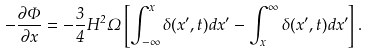Convert formula to latex. <formula><loc_0><loc_0><loc_500><loc_500>- \frac { \partial \Phi } { \partial x } = - \frac { 3 } { 4 } H ^ { 2 } \Omega \left [ \int ^ { x } _ { - \infty } \delta ( x ^ { \prime } , t ) d x ^ { \prime } - \int ^ { \infty } _ { x } \delta ( x ^ { \prime } , t ) d x ^ { \prime } \right ] .</formula> 